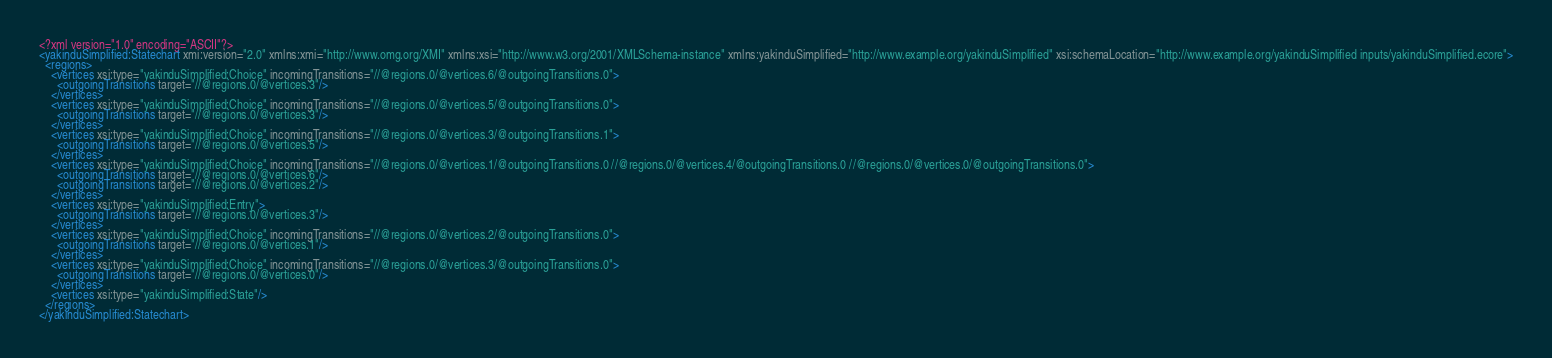Convert code to text. <code><loc_0><loc_0><loc_500><loc_500><_XML_><?xml version="1.0" encoding="ASCII"?>
<yakinduSimplified:Statechart xmi:version="2.0" xmlns:xmi="http://www.omg.org/XMI" xmlns:xsi="http://www.w3.org/2001/XMLSchema-instance" xmlns:yakinduSimplified="http://www.example.org/yakinduSimplified" xsi:schemaLocation="http://www.example.org/yakinduSimplified inputs/yakinduSimplified.ecore">
  <regions>
    <vertices xsi:type="yakinduSimplified:Choice" incomingTransitions="//@regions.0/@vertices.6/@outgoingTransitions.0">
      <outgoingTransitions target="//@regions.0/@vertices.3"/>
    </vertices>
    <vertices xsi:type="yakinduSimplified:Choice" incomingTransitions="//@regions.0/@vertices.5/@outgoingTransitions.0">
      <outgoingTransitions target="//@regions.0/@vertices.3"/>
    </vertices>
    <vertices xsi:type="yakinduSimplified:Choice" incomingTransitions="//@regions.0/@vertices.3/@outgoingTransitions.1">
      <outgoingTransitions target="//@regions.0/@vertices.5"/>
    </vertices>
    <vertices xsi:type="yakinduSimplified:Choice" incomingTransitions="//@regions.0/@vertices.1/@outgoingTransitions.0 //@regions.0/@vertices.4/@outgoingTransitions.0 //@regions.0/@vertices.0/@outgoingTransitions.0">
      <outgoingTransitions target="//@regions.0/@vertices.6"/>
      <outgoingTransitions target="//@regions.0/@vertices.2"/>
    </vertices>
    <vertices xsi:type="yakinduSimplified:Entry">
      <outgoingTransitions target="//@regions.0/@vertices.3"/>
    </vertices>
    <vertices xsi:type="yakinduSimplified:Choice" incomingTransitions="//@regions.0/@vertices.2/@outgoingTransitions.0">
      <outgoingTransitions target="//@regions.0/@vertices.1"/>
    </vertices>
    <vertices xsi:type="yakinduSimplified:Choice" incomingTransitions="//@regions.0/@vertices.3/@outgoingTransitions.0">
      <outgoingTransitions target="//@regions.0/@vertices.0"/>
    </vertices>
    <vertices xsi:type="yakinduSimplified:State"/>
  </regions>
</yakinduSimplified:Statechart>
</code> 